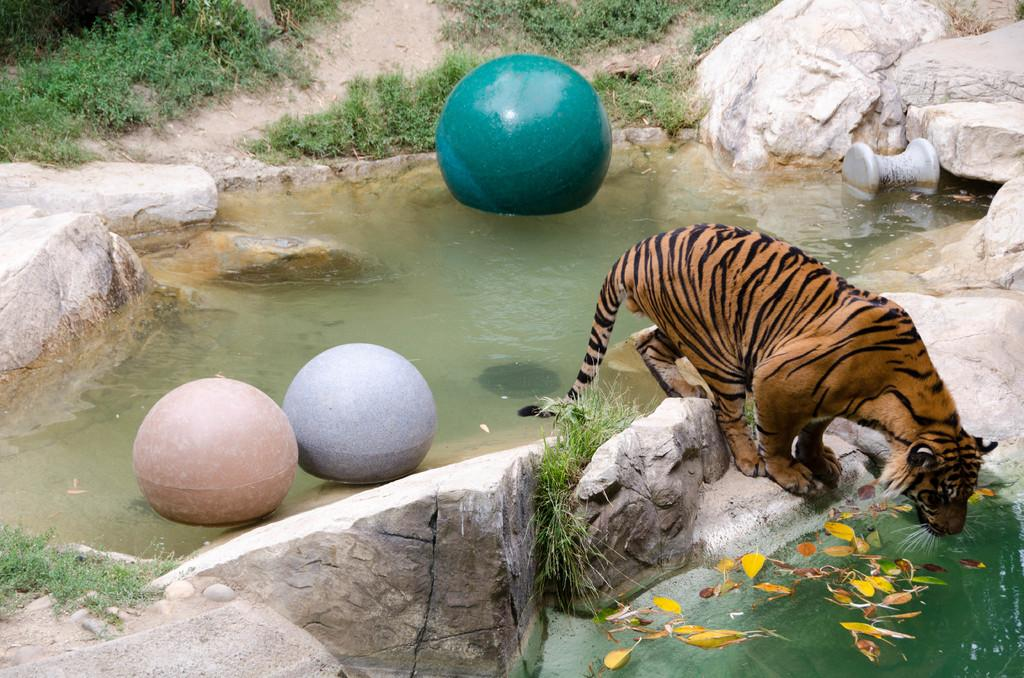What animal is in the picture? There is a tiger in the picture. What is the tiger standing on? The tiger is standing on a stone surface. What can be seen besides the tiger in the image? There is water visible in the image, as well as balloons. What type of vegetation is in the background of the picture? There is grass in the background of the picture. What type of alarm can be heard going off in the image? There is no alarm present in the image, so it cannot be heard. 